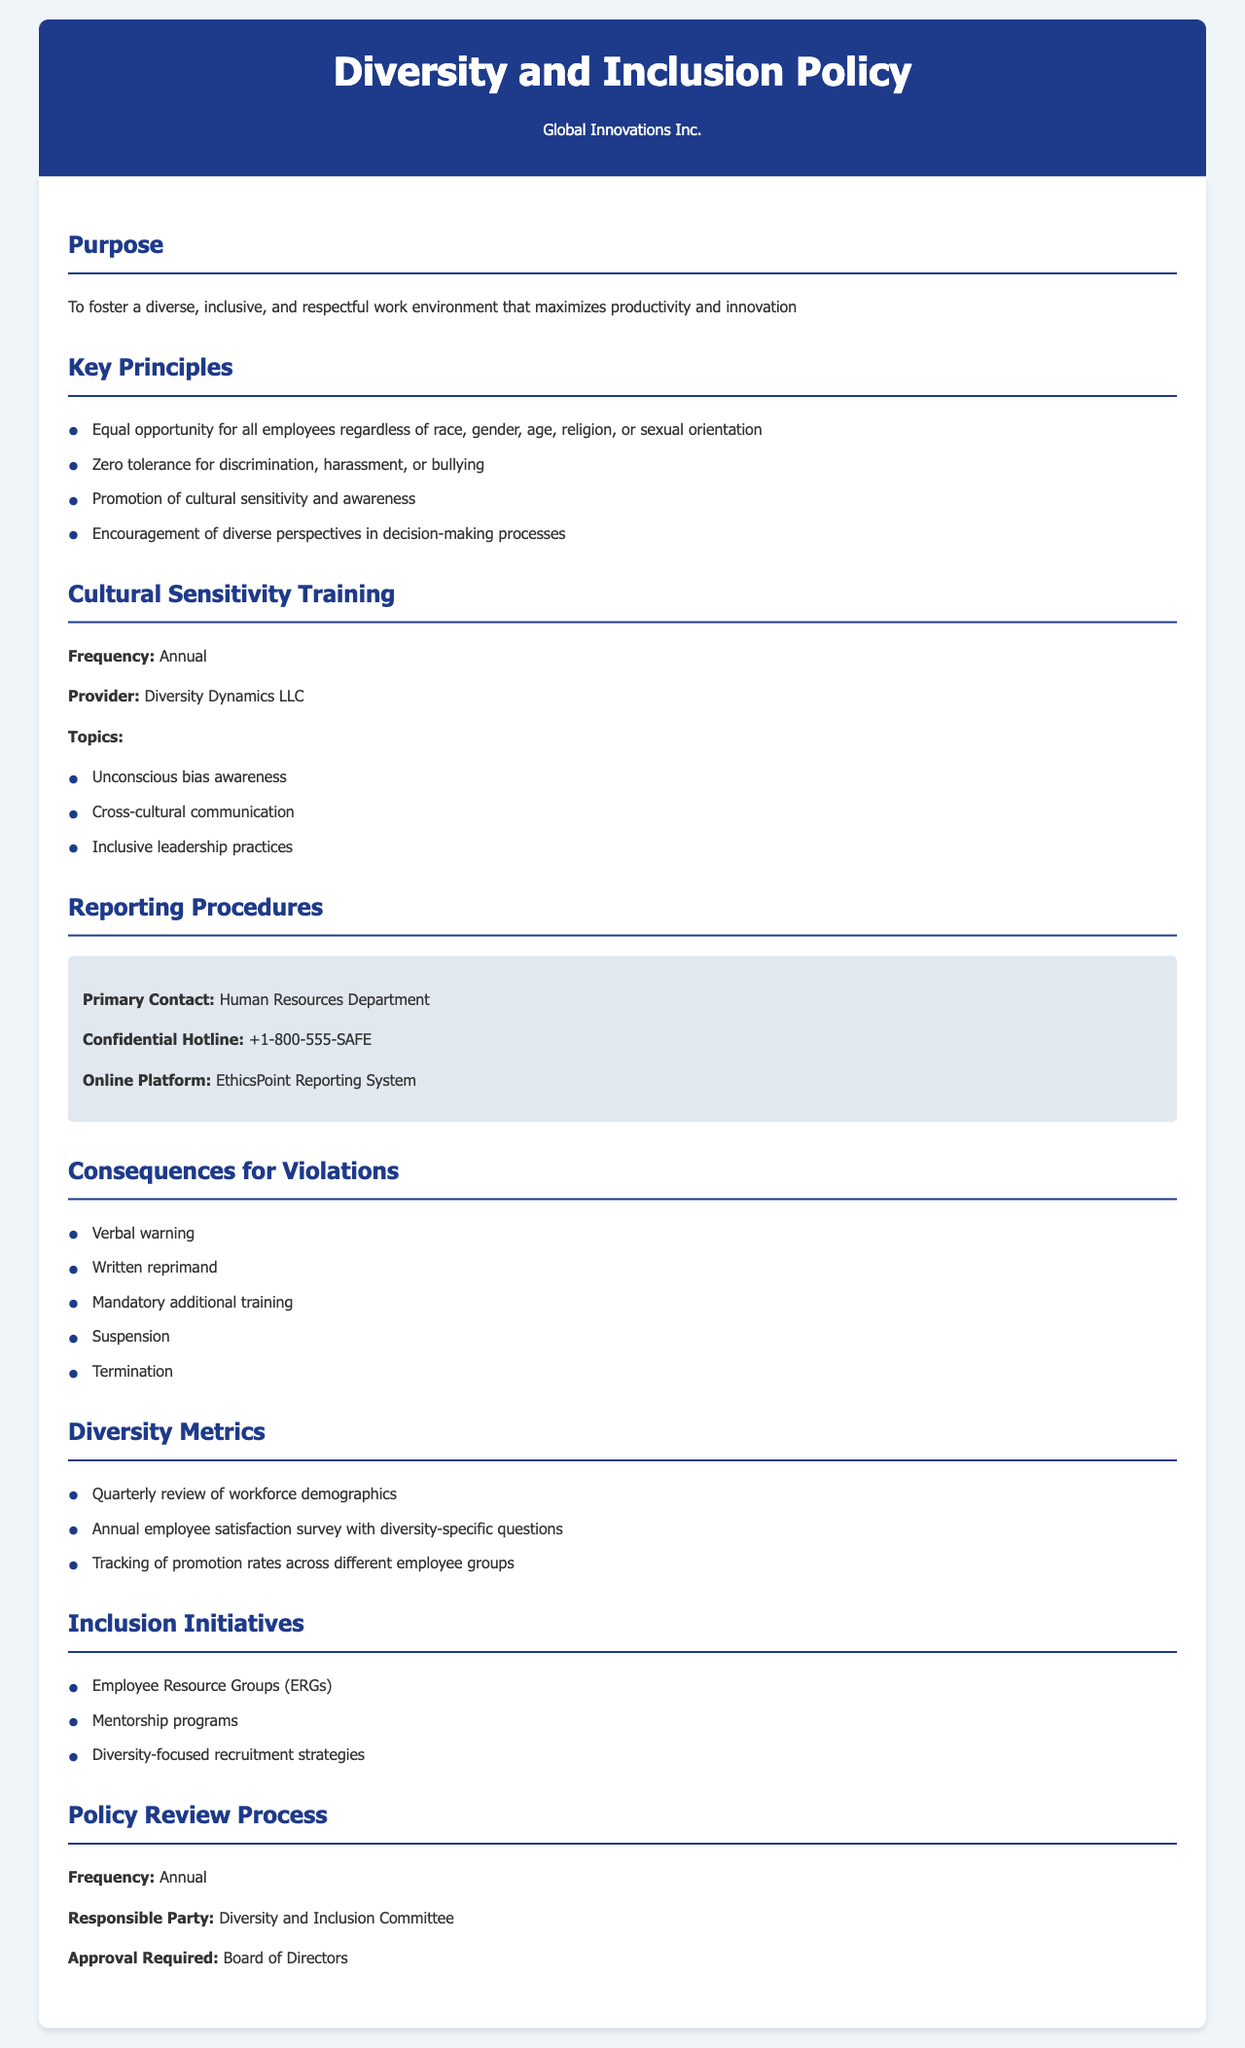What is the frequency of cultural sensitivity training? The document states that cultural sensitivity training occurs annually.
Answer: Annual Who is the provider for the cultural sensitivity training? The training is provided by Diversity Dynamics LLC.
Answer: Diversity Dynamics LLC What hotline should employees contact for reporting issues? The confidential hotline number provided in the document is +1-800-555-SAFE.
Answer: +1-800-555-SAFE What does the policy's purpose focus on? The purpose is to foster a diverse, inclusive, and respectful work environment that maximizes productivity and innovation.
Answer: Diverse, inclusive, and respectful work environment What is one of the consequences for violations mentioned? Consequences listed include a verbal warning for violations.
Answer: Verbal warning Who is responsible for the policy review process? The responsible party for the policy review process is the Diversity and Inclusion Committee.
Answer: Diversity and Inclusion Committee What type of initiatives does the policy include for inclusion? The policy includes Employee Resource Groups among its inclusion initiatives.
Answer: Employee Resource Groups What is the approval required for the policy review? The document states that approval is required from the Board of Directors.
Answer: Board of Directors What is the key principle regarding discrimination in the workplace? The policy states there is a zero tolerance for discrimination, harassment, or bullying.
Answer: Zero tolerance for discrimination, harassment, or bullying 